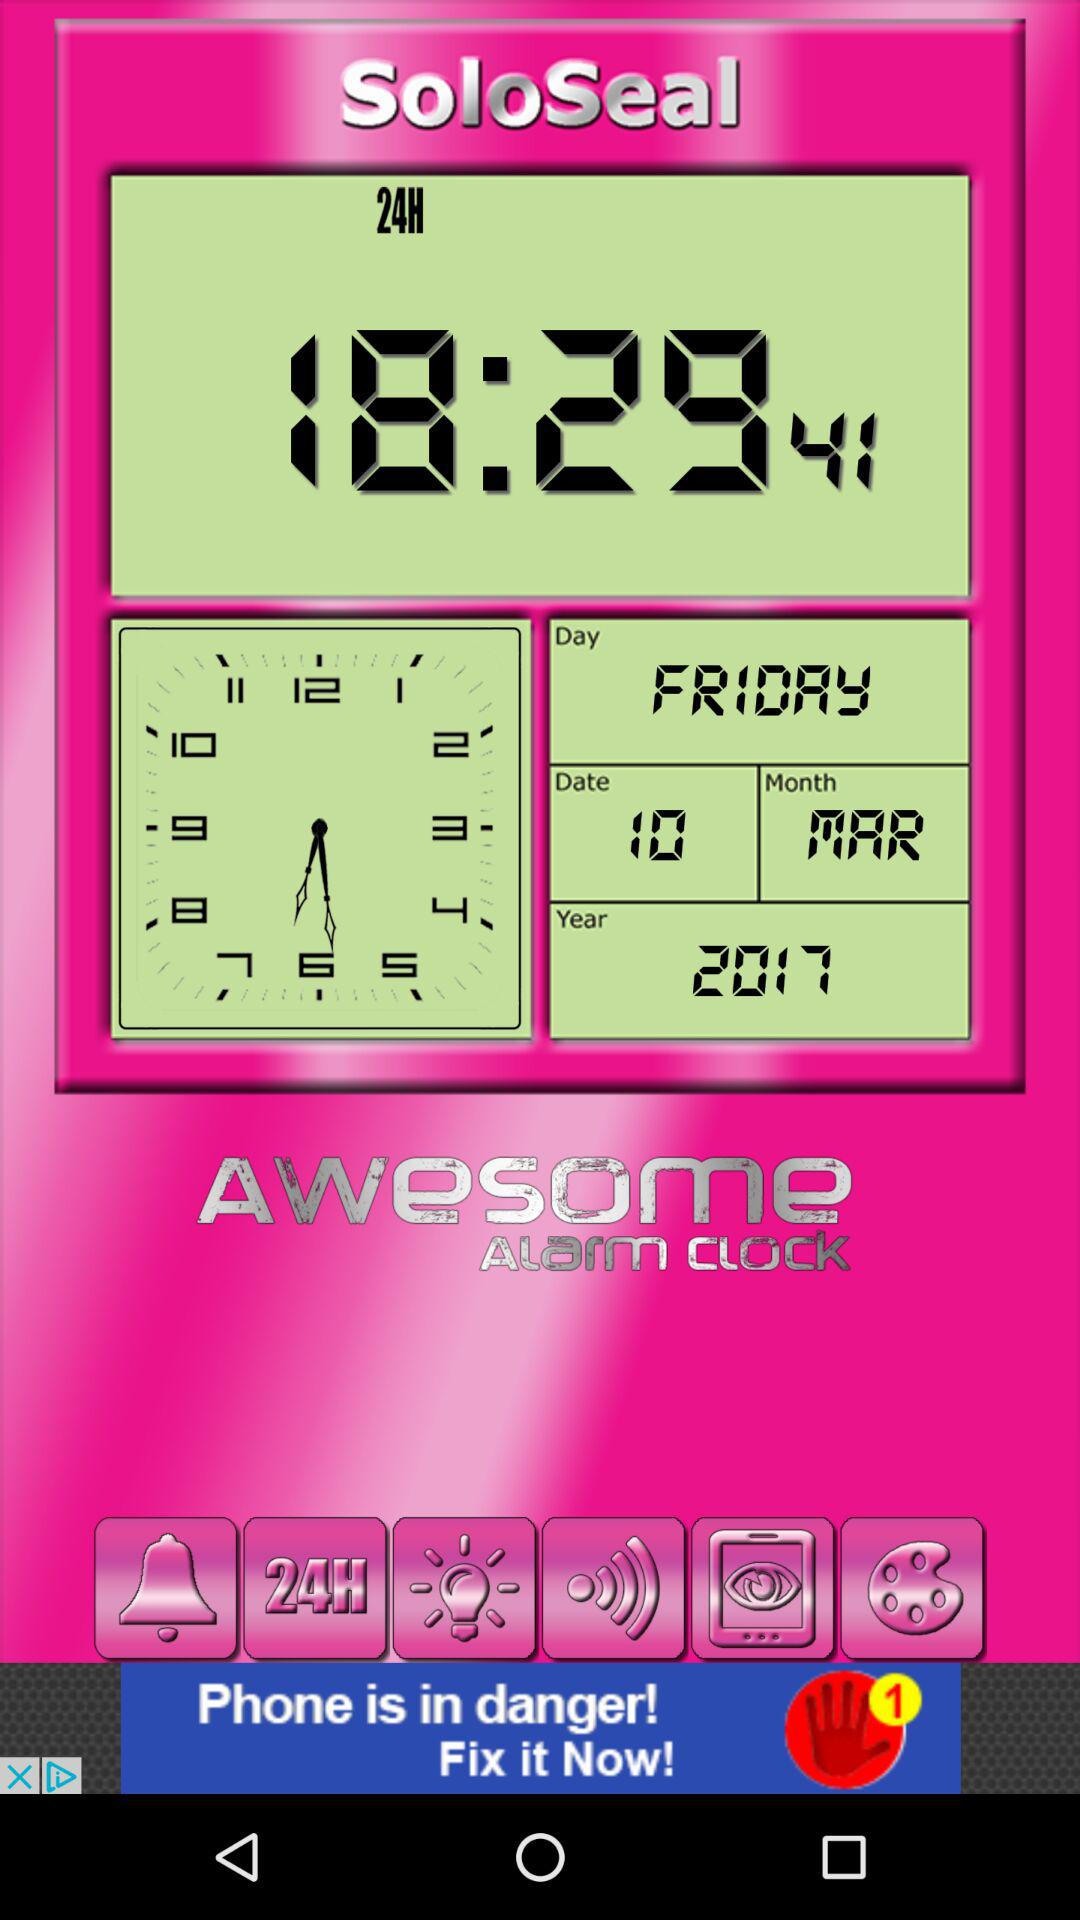What is the current time? The current time is 18:29:41. 